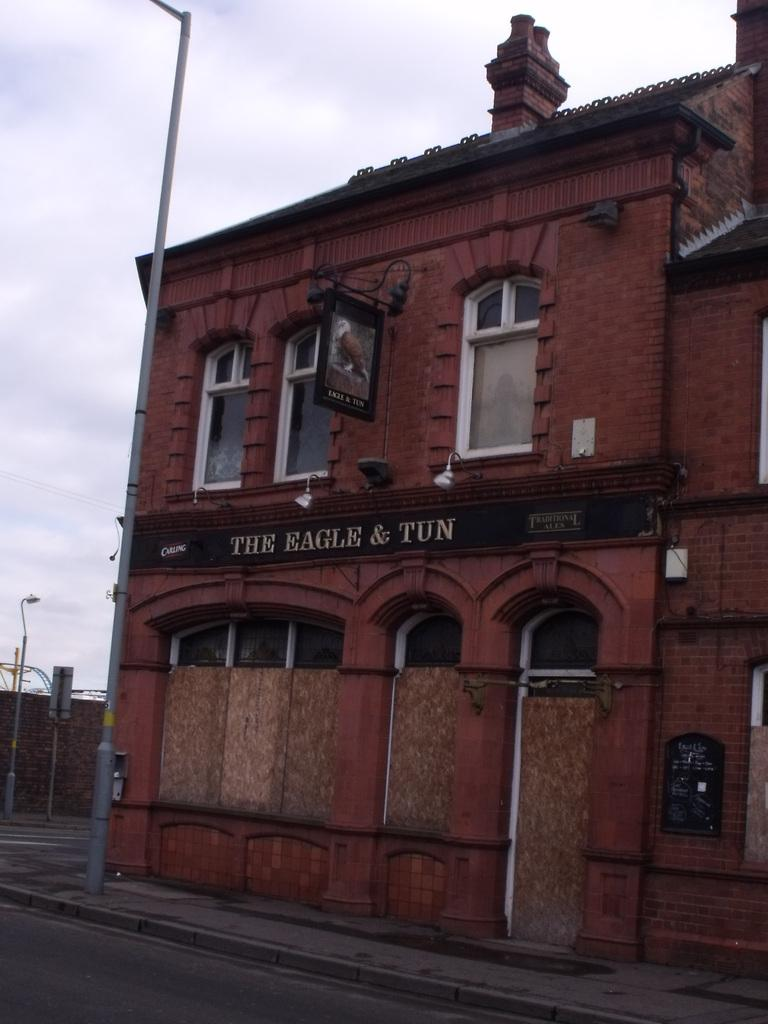What type of building is visible in the image? There is a building with glass windows in the image. What can be seen on the left side of the image? There is a pole on the left side of the image. What is visible at the top of the image? The sky is visible at the top of the image. What flavor of goose is being served for breakfast in the image? There is no goose or breakfast present in the image, so it is not possible to determine the flavor of any goose being served. 